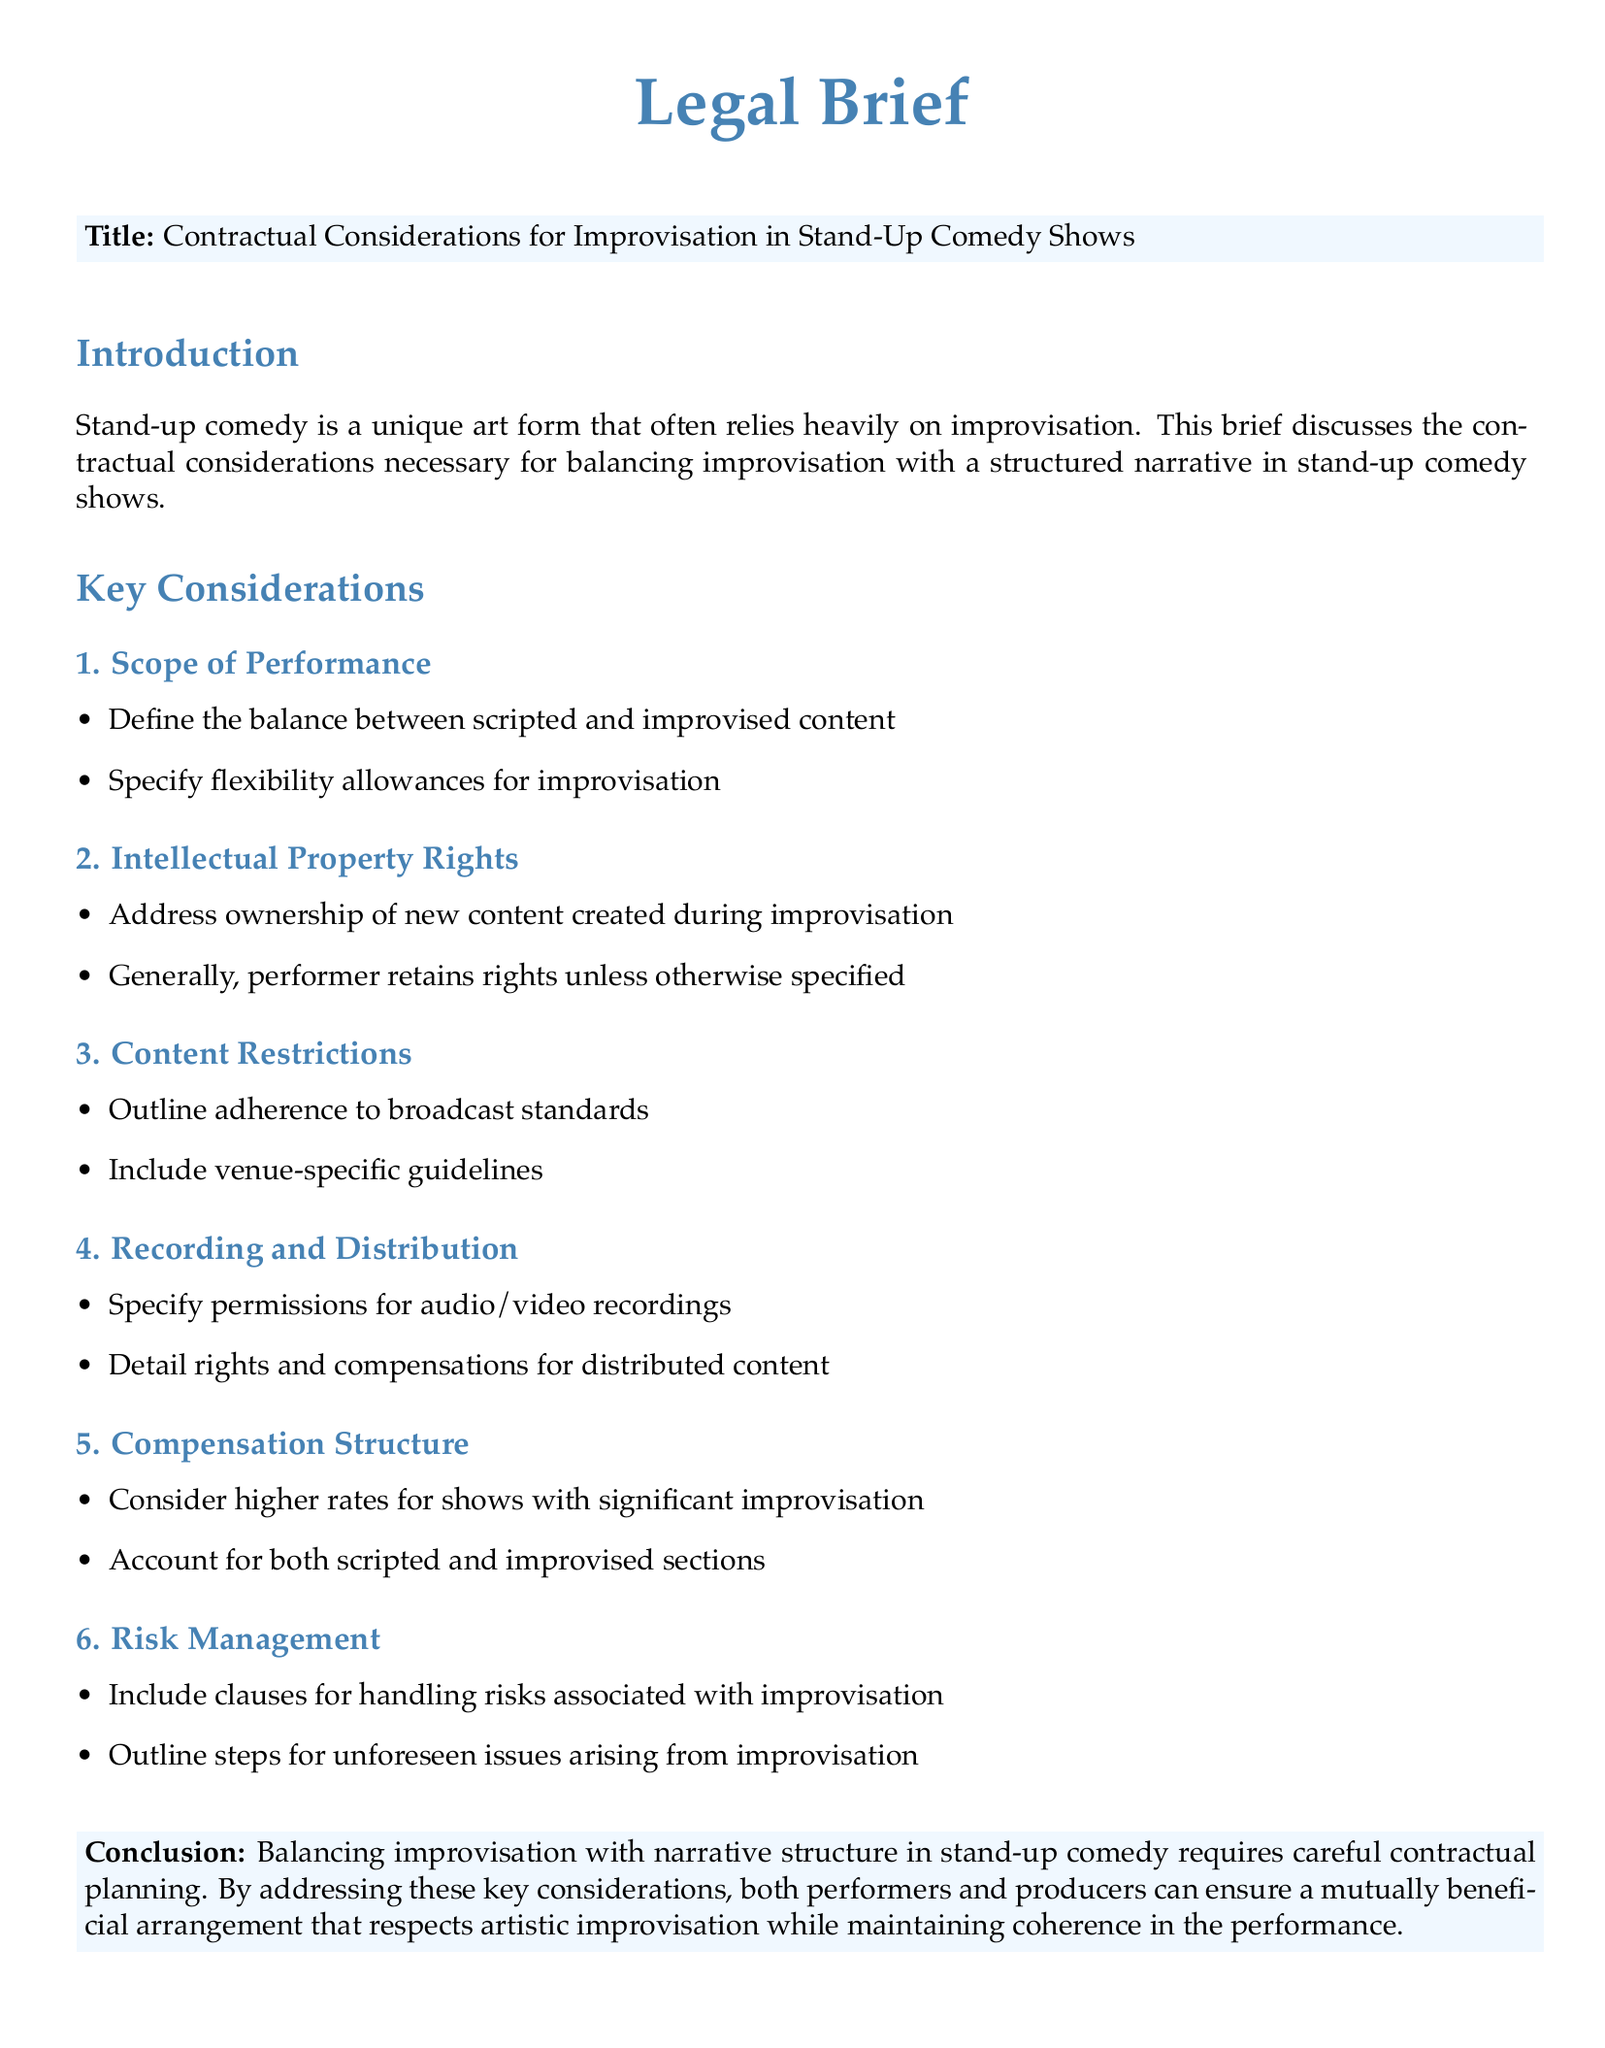What is the title of the brief? The title of the brief is mentioned in the document under the section with a colorbox, specifically addressing the primary subject.
Answer: Contractual Considerations for Improvisation in Stand-Up Comedy Shows What is one key consideration mentioned in the brief? The document outlines several key considerations, listed as subsections that are crucial for understanding the contractual aspects of improvisation in comedy.
Answer: Scope of Performance Who generally retains rights to new content created during improvisation? The brief discusses intellectual property rights and specifies who typically holds ownership of improvisational content.
Answer: Performer What must be outlined regarding risks associated with improvisation? The document suggests including certain clauses in contracts to address potential risks and unforeseen issues that may arise, particularly focusing on what should be managed.
Answer: Clauses for handling risks What does the compensation structure consider? The compensation structure detailed in the brief discusses how different types of performance content may affect payment rates.
Answer: Higher rates for shows with significant improvisation How does the brief conclude regarding contractual planning? The conclusion summarizes the importance of proper contractual considerations, reflecting on the relationship between improvisation and narrative structure in stand-up comedy performances.
Answer: Careful contractual planning 